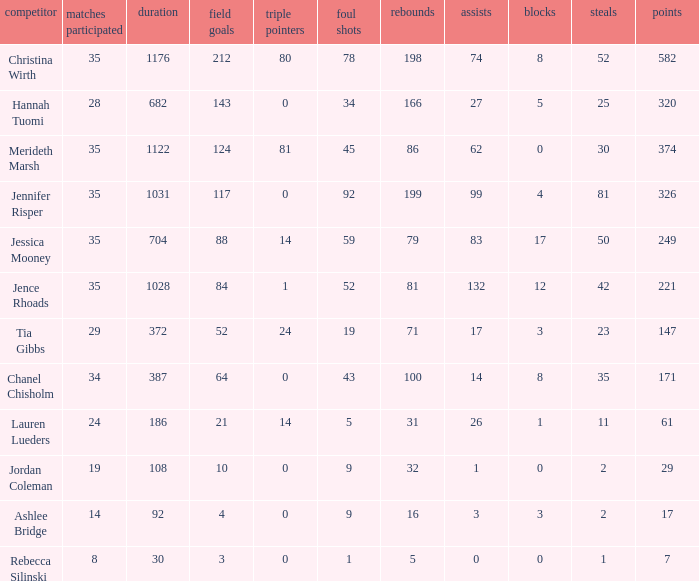How much time, in minutes, did Chanel Chisholm play? 1.0. 